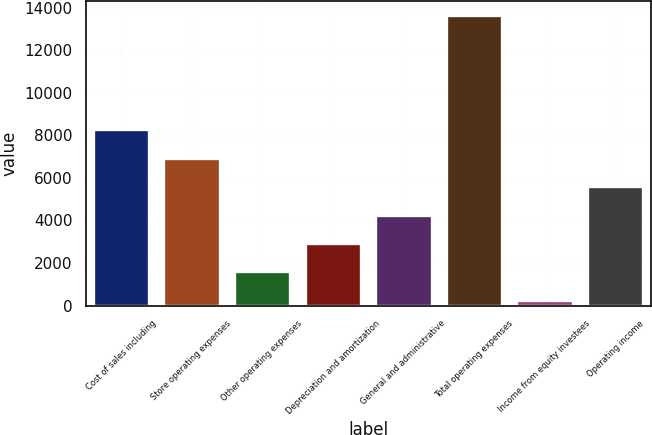<chart> <loc_0><loc_0><loc_500><loc_500><bar_chart><fcel>Cost of sales including<fcel>Store operating expenses<fcel>Other operating expenses<fcel>Depreciation and amortization<fcel>General and administrative<fcel>Total operating expenses<fcel>Income from equity investees<fcel>Operating income<nl><fcel>8288.32<fcel>6951.65<fcel>1604.97<fcel>2941.64<fcel>4278.31<fcel>13635<fcel>268.3<fcel>5614.98<nl></chart> 